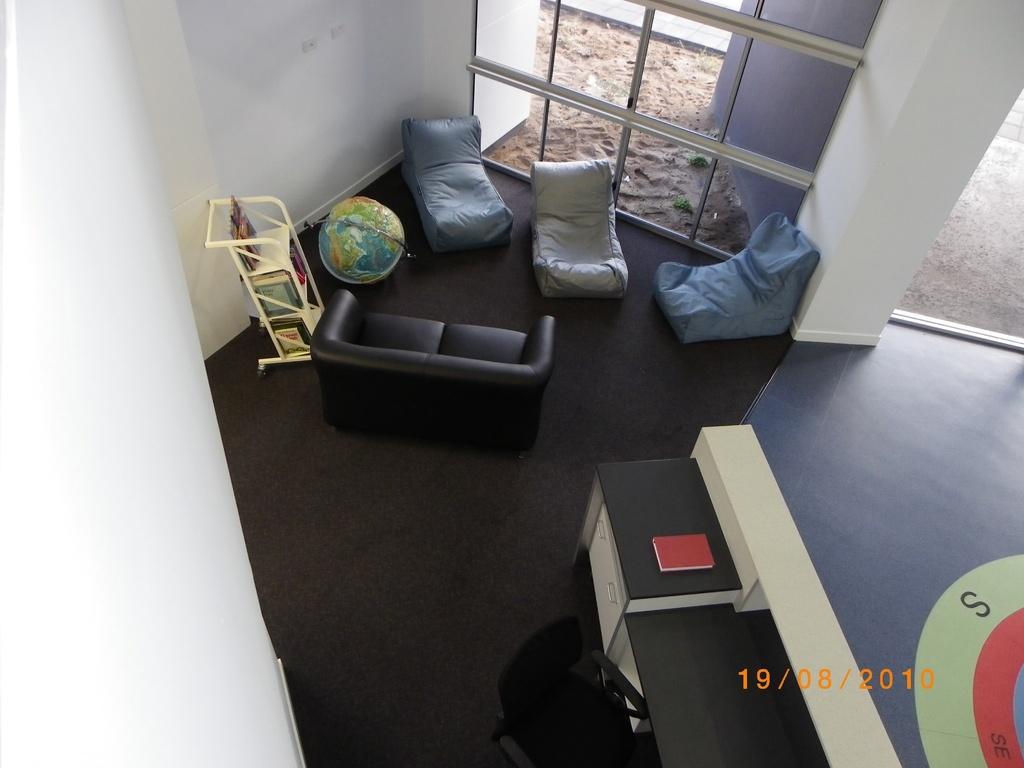How would you summarize this image in a sentence or two? This picture describes about interior of the room, in this we can find sofas, stand and chair, and also we can find a book on the table and walls. 